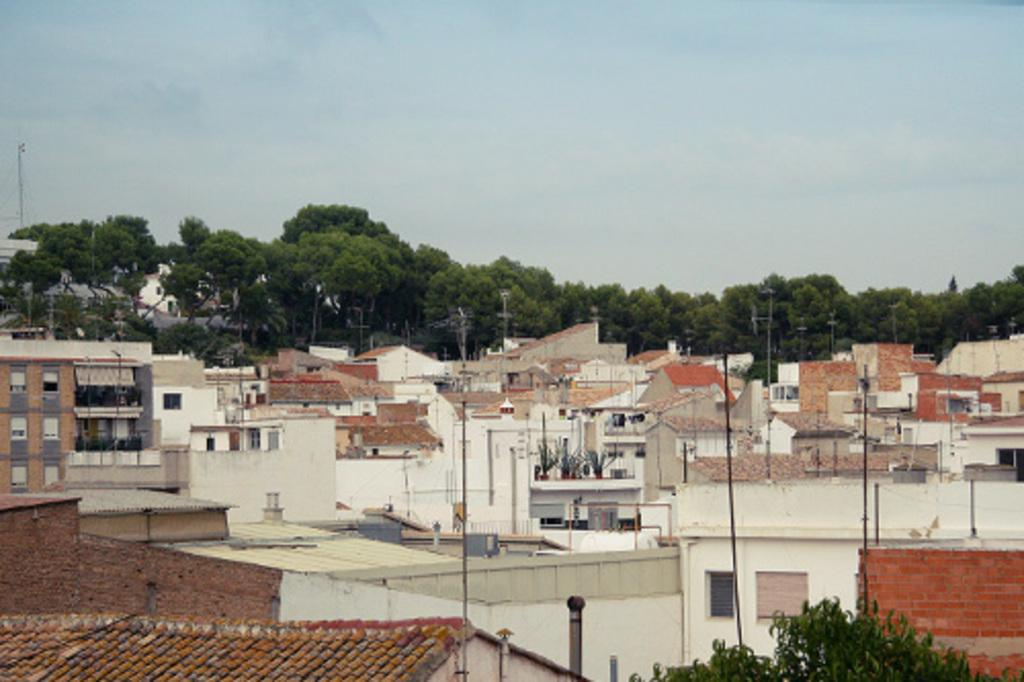What type of structures are present in the image? There are many houses in the image. What colors are the houses in the image? The houses are in white and brown colors. What can be seen in the background of the image? There are many trees visible in the background, and the sky is also visible. How much money is being exchanged between the houses in the image? There is no indication of money being exchanged between the houses in the image. What type of approval is required for the structures in the image? There is no information about any approval process for the structures in the image. 